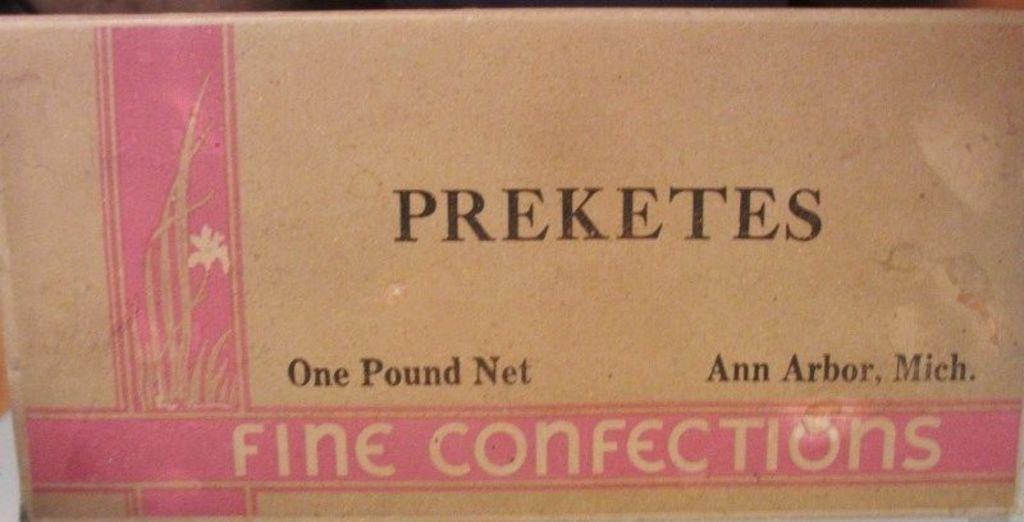What item did this preketes box caries ?
Offer a terse response. Fine confections. How much does the bow weight?
Offer a terse response. One pound. 